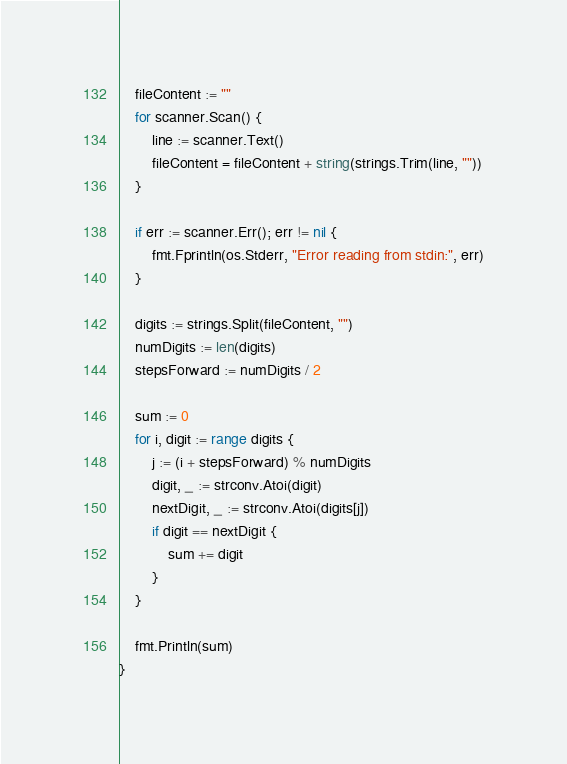<code> <loc_0><loc_0><loc_500><loc_500><_Go_>	fileContent := ""
	for scanner.Scan() {
		line := scanner.Text()
		fileContent = fileContent + string(strings.Trim(line, ""))
	}

	if err := scanner.Err(); err != nil {
		fmt.Fprintln(os.Stderr, "Error reading from stdin:", err)
	}

	digits := strings.Split(fileContent, "")
	numDigits := len(digits)
	stepsForward := numDigits / 2

	sum := 0
	for i, digit := range digits {
		j := (i + stepsForward) % numDigits
		digit, _ := strconv.Atoi(digit)
		nextDigit, _ := strconv.Atoi(digits[j])
		if digit == nextDigit {
			sum += digit
		}
	}

	fmt.Println(sum)
}</code> 